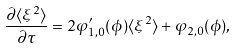Convert formula to latex. <formula><loc_0><loc_0><loc_500><loc_500>\frac { \partial \langle \xi ^ { 2 } \rangle } { \partial \tau } = 2 \varphi _ { 1 , 0 } ^ { \prime } ( \phi ) \langle \xi ^ { 2 } \rangle + \varphi _ { 2 , 0 } ( \phi ) ,</formula> 